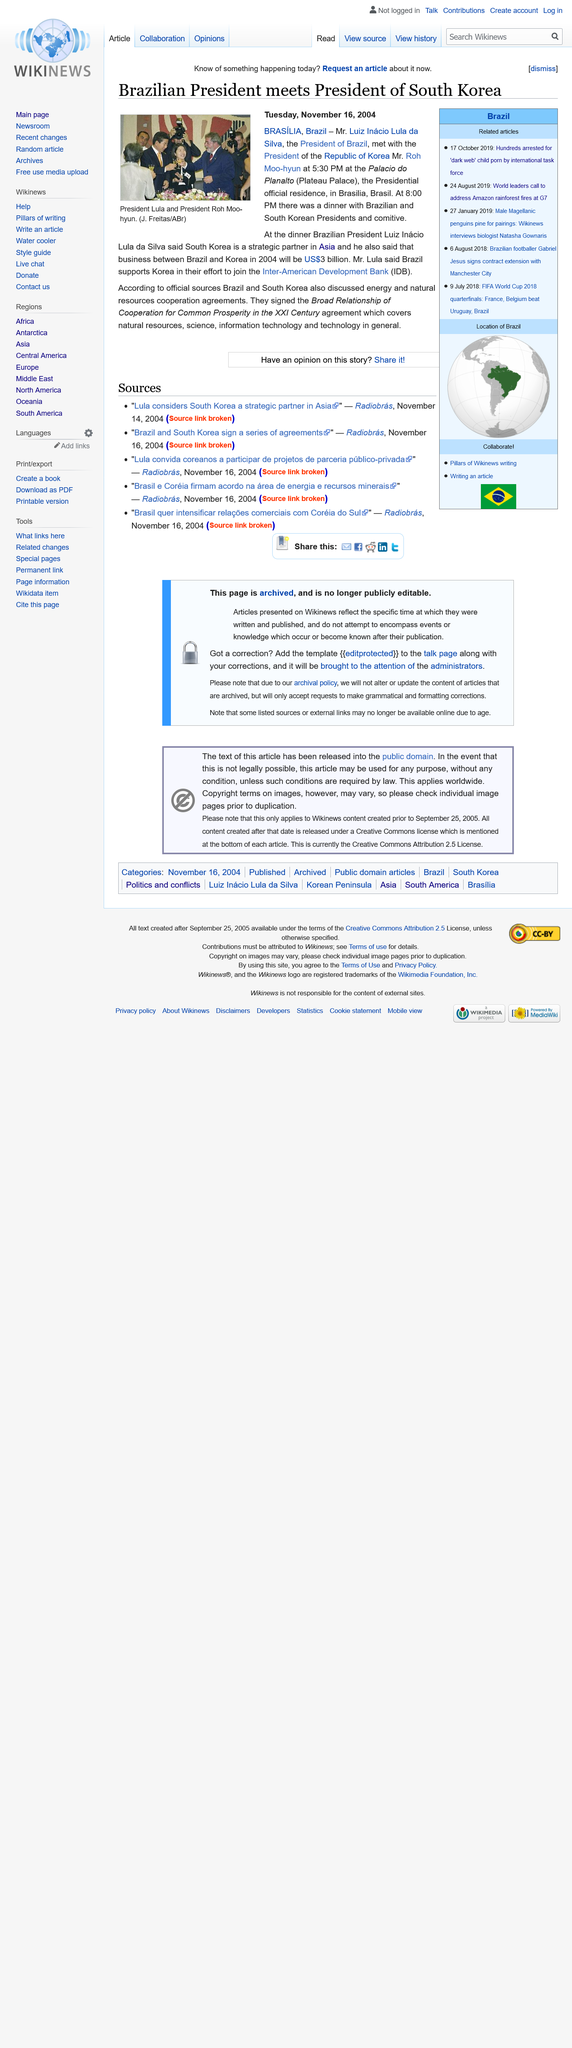Indicate a few pertinent items in this graphic. This report was published on Tuesday, November 16, 2004. The meeting took place in Plateau Palace. The individuals depicted in the image are President Lula and President Roh Moo-hyun. 